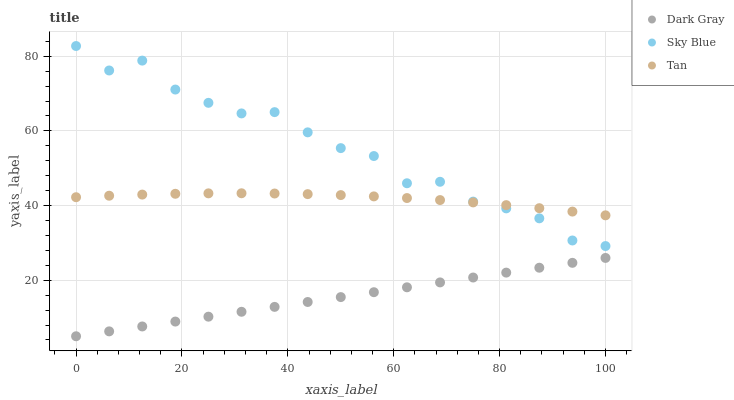Does Dark Gray have the minimum area under the curve?
Answer yes or no. Yes. Does Sky Blue have the maximum area under the curve?
Answer yes or no. Yes. Does Tan have the minimum area under the curve?
Answer yes or no. No. Does Tan have the maximum area under the curve?
Answer yes or no. No. Is Dark Gray the smoothest?
Answer yes or no. Yes. Is Sky Blue the roughest?
Answer yes or no. Yes. Is Tan the smoothest?
Answer yes or no. No. Is Tan the roughest?
Answer yes or no. No. Does Dark Gray have the lowest value?
Answer yes or no. Yes. Does Sky Blue have the lowest value?
Answer yes or no. No. Does Sky Blue have the highest value?
Answer yes or no. Yes. Does Tan have the highest value?
Answer yes or no. No. Is Dark Gray less than Sky Blue?
Answer yes or no. Yes. Is Sky Blue greater than Dark Gray?
Answer yes or no. Yes. Does Tan intersect Sky Blue?
Answer yes or no. Yes. Is Tan less than Sky Blue?
Answer yes or no. No. Is Tan greater than Sky Blue?
Answer yes or no. No. Does Dark Gray intersect Sky Blue?
Answer yes or no. No. 